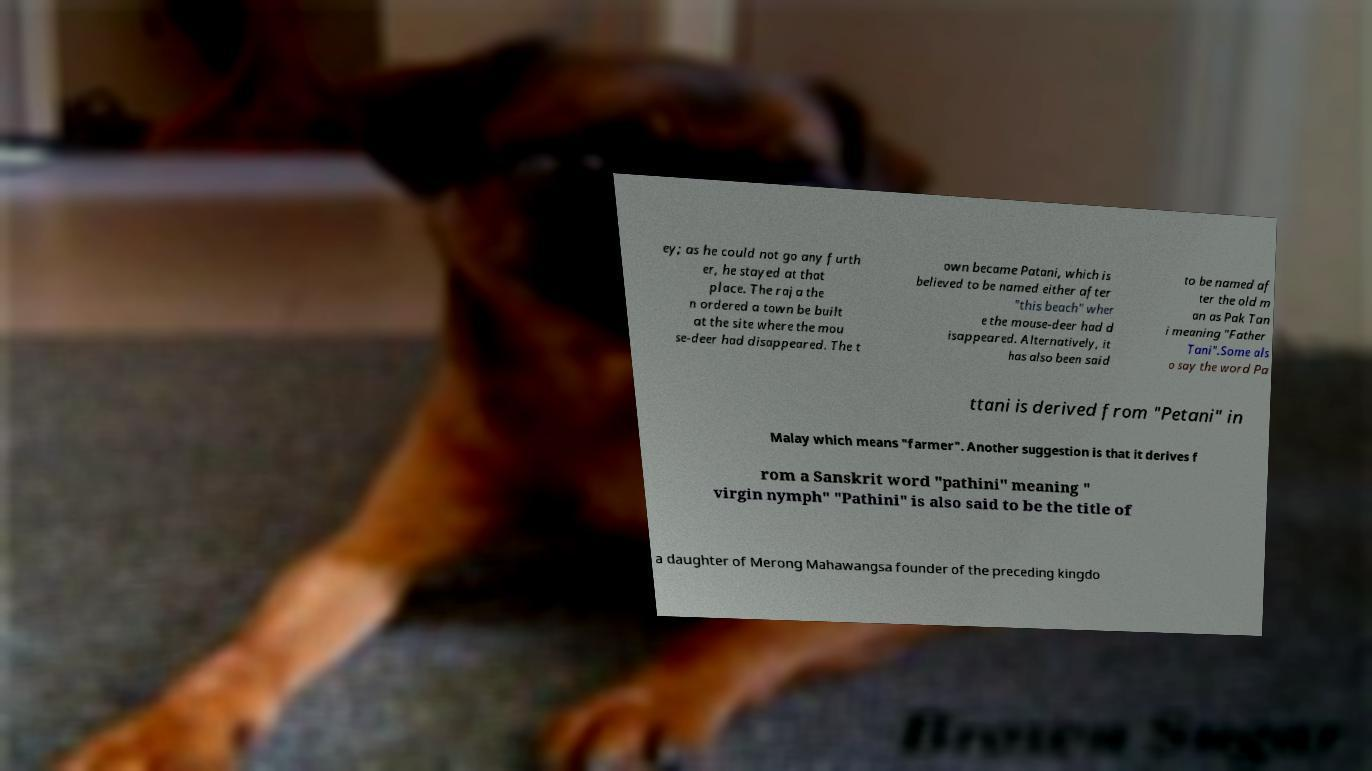For documentation purposes, I need the text within this image transcribed. Could you provide that? ey; as he could not go any furth er, he stayed at that place. The raja the n ordered a town be built at the site where the mou se-deer had disappeared. The t own became Patani, which is believed to be named either after "this beach" wher e the mouse-deer had d isappeared. Alternatively, it has also been said to be named af ter the old m an as Pak Tan i meaning "Father Tani".Some als o say the word Pa ttani is derived from "Petani" in Malay which means "farmer". Another suggestion is that it derives f rom a Sanskrit word "pathini" meaning " virgin nymph" "Pathini" is also said to be the title of a daughter of Merong Mahawangsa founder of the preceding kingdo 